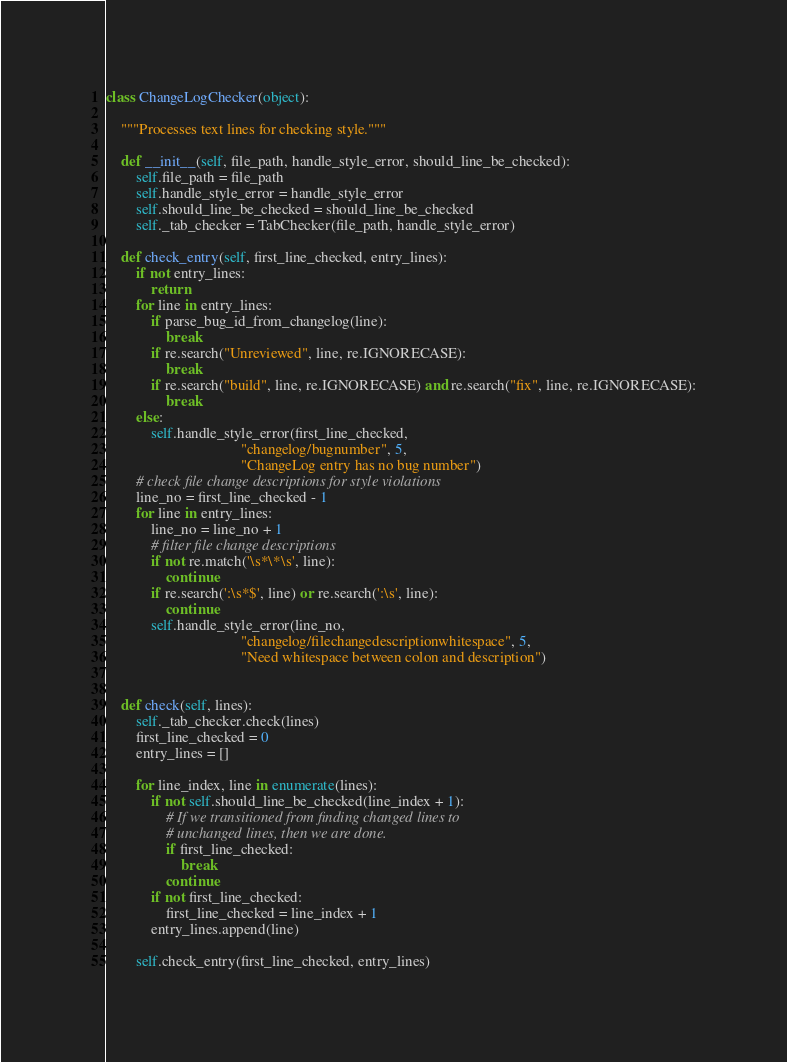<code> <loc_0><loc_0><loc_500><loc_500><_Python_>class ChangeLogChecker(object):

    """Processes text lines for checking style."""

    def __init__(self, file_path, handle_style_error, should_line_be_checked):
        self.file_path = file_path
        self.handle_style_error = handle_style_error
        self.should_line_be_checked = should_line_be_checked
        self._tab_checker = TabChecker(file_path, handle_style_error)

    def check_entry(self, first_line_checked, entry_lines):
        if not entry_lines:
            return
        for line in entry_lines:
            if parse_bug_id_from_changelog(line):
                break
            if re.search("Unreviewed", line, re.IGNORECASE):
                break
            if re.search("build", line, re.IGNORECASE) and re.search("fix", line, re.IGNORECASE):
                break
        else:
            self.handle_style_error(first_line_checked,
                                    "changelog/bugnumber", 5,
                                    "ChangeLog entry has no bug number")
        # check file change descriptions for style violations
        line_no = first_line_checked - 1
        for line in entry_lines:
            line_no = line_no + 1
            # filter file change descriptions
            if not re.match('\s*\*\s', line):
                continue
            if re.search(':\s*$', line) or re.search(':\s', line):
                continue
            self.handle_style_error(line_no,
                                    "changelog/filechangedescriptionwhitespace", 5,
                                    "Need whitespace between colon and description")


    def check(self, lines):
        self._tab_checker.check(lines)
        first_line_checked = 0
        entry_lines = []

        for line_index, line in enumerate(lines):
            if not self.should_line_be_checked(line_index + 1):
                # If we transitioned from finding changed lines to
                # unchanged lines, then we are done.
                if first_line_checked:
                    break
                continue
            if not first_line_checked:
                first_line_checked = line_index + 1
            entry_lines.append(line)

        self.check_entry(first_line_checked, entry_lines)
</code> 